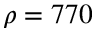Convert formula to latex. <formula><loc_0><loc_0><loc_500><loc_500>\rho = 7 7 0</formula> 